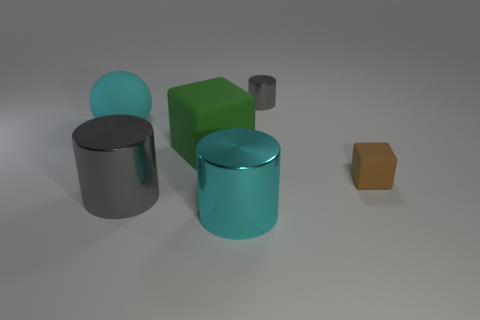Subtract all small gray cylinders. How many cylinders are left? 2 Add 4 cyan rubber balls. How many objects exist? 10 Subtract all balls. How many objects are left? 5 Add 4 tiny gray cylinders. How many tiny gray cylinders are left? 5 Add 6 tiny cyan metallic things. How many tiny cyan metallic things exist? 6 Subtract 0 blue cylinders. How many objects are left? 6 Subtract all cyan spheres. Subtract all spheres. How many objects are left? 4 